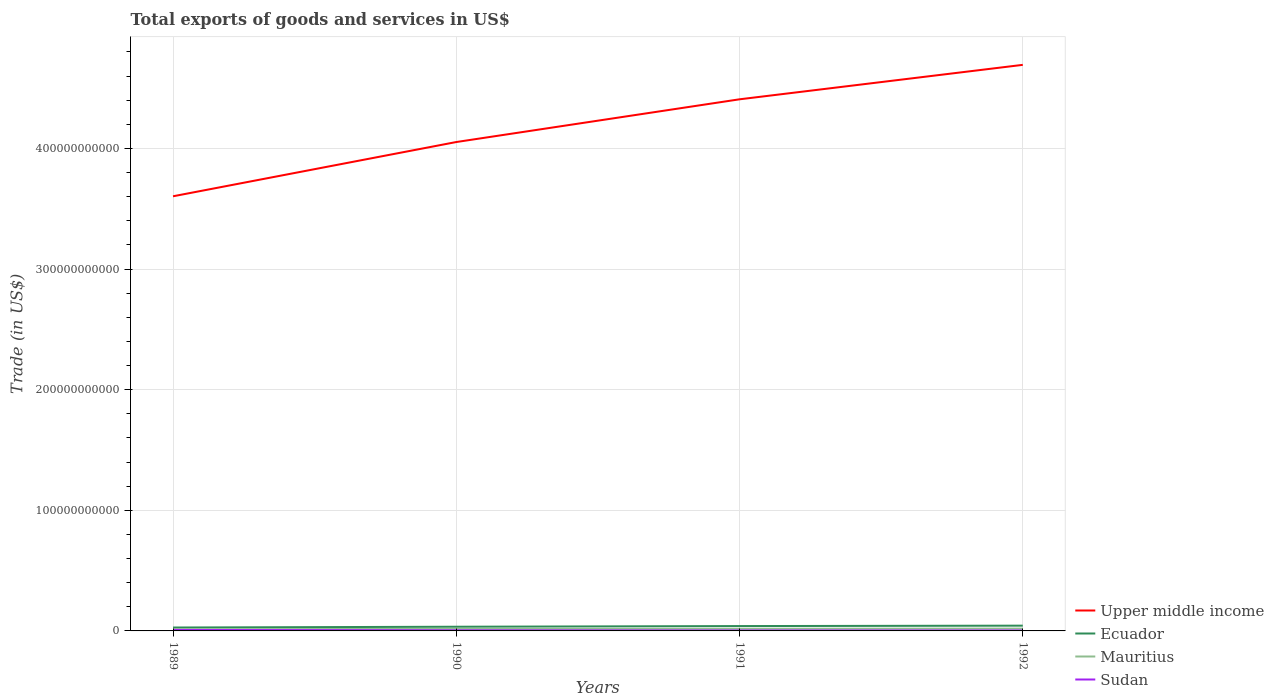How many different coloured lines are there?
Your answer should be compact. 4. Is the number of lines equal to the number of legend labels?
Ensure brevity in your answer.  Yes. Across all years, what is the maximum total exports of goods and services in Mauritius?
Make the answer very short. 1.40e+09. What is the total total exports of goods and services in Upper middle income in the graph?
Give a very brief answer. -3.54e+1. What is the difference between the highest and the second highest total exports of goods and services in Sudan?
Offer a very short reply. 4.48e+08. Is the total exports of goods and services in Mauritius strictly greater than the total exports of goods and services in Sudan over the years?
Provide a short and direct response. No. How many lines are there?
Provide a short and direct response. 4. What is the difference between two consecutive major ticks on the Y-axis?
Your answer should be very brief. 1.00e+11. Where does the legend appear in the graph?
Ensure brevity in your answer.  Bottom right. How many legend labels are there?
Keep it short and to the point. 4. What is the title of the graph?
Your response must be concise. Total exports of goods and services in US$. Does "Liechtenstein" appear as one of the legend labels in the graph?
Provide a succinct answer. No. What is the label or title of the X-axis?
Offer a very short reply. Years. What is the label or title of the Y-axis?
Ensure brevity in your answer.  Trade (in US$). What is the Trade (in US$) of Upper middle income in 1989?
Offer a very short reply. 3.60e+11. What is the Trade (in US$) in Ecuador in 1989?
Your answer should be compact. 2.82e+09. What is the Trade (in US$) of Mauritius in 1989?
Give a very brief answer. 1.40e+09. What is the Trade (in US$) in Sudan in 1989?
Your response must be concise. 8.17e+08. What is the Trade (in US$) in Upper middle income in 1990?
Your answer should be very brief. 4.05e+11. What is the Trade (in US$) in Ecuador in 1990?
Your answer should be very brief. 3.47e+09. What is the Trade (in US$) of Mauritius in 1990?
Offer a very short reply. 1.72e+09. What is the Trade (in US$) of Sudan in 1990?
Offer a very short reply. 4.99e+08. What is the Trade (in US$) of Upper middle income in 1991?
Your answer should be compact. 4.41e+11. What is the Trade (in US$) of Ecuador in 1991?
Ensure brevity in your answer.  4.02e+09. What is the Trade (in US$) of Mauritius in 1991?
Your response must be concise. 1.78e+09. What is the Trade (in US$) of Sudan in 1991?
Keep it short and to the point. 3.80e+08. What is the Trade (in US$) in Upper middle income in 1992?
Give a very brief answer. 4.69e+11. What is the Trade (in US$) in Ecuador in 1992?
Offer a terse response. 4.37e+09. What is the Trade (in US$) of Mauritius in 1992?
Your response must be concise. 1.91e+09. What is the Trade (in US$) of Sudan in 1992?
Provide a succinct answer. 3.69e+08. Across all years, what is the maximum Trade (in US$) in Upper middle income?
Provide a short and direct response. 4.69e+11. Across all years, what is the maximum Trade (in US$) in Ecuador?
Ensure brevity in your answer.  4.37e+09. Across all years, what is the maximum Trade (in US$) in Mauritius?
Your answer should be compact. 1.91e+09. Across all years, what is the maximum Trade (in US$) in Sudan?
Make the answer very short. 8.17e+08. Across all years, what is the minimum Trade (in US$) of Upper middle income?
Provide a succinct answer. 3.60e+11. Across all years, what is the minimum Trade (in US$) of Ecuador?
Ensure brevity in your answer.  2.82e+09. Across all years, what is the minimum Trade (in US$) in Mauritius?
Provide a succinct answer. 1.40e+09. Across all years, what is the minimum Trade (in US$) in Sudan?
Keep it short and to the point. 3.69e+08. What is the total Trade (in US$) of Upper middle income in the graph?
Offer a terse response. 1.68e+12. What is the total Trade (in US$) in Ecuador in the graph?
Provide a succinct answer. 1.47e+1. What is the total Trade (in US$) in Mauritius in the graph?
Your response must be concise. 6.82e+09. What is the total Trade (in US$) of Sudan in the graph?
Your answer should be compact. 2.06e+09. What is the difference between the Trade (in US$) in Upper middle income in 1989 and that in 1990?
Your answer should be very brief. -4.50e+1. What is the difference between the Trade (in US$) in Ecuador in 1989 and that in 1990?
Your answer should be compact. -6.52e+08. What is the difference between the Trade (in US$) of Mauritius in 1989 and that in 1990?
Your answer should be compact. -3.23e+08. What is the difference between the Trade (in US$) of Sudan in 1989 and that in 1990?
Provide a short and direct response. 3.18e+08. What is the difference between the Trade (in US$) of Upper middle income in 1989 and that in 1991?
Provide a succinct answer. -8.04e+1. What is the difference between the Trade (in US$) of Ecuador in 1989 and that in 1991?
Ensure brevity in your answer.  -1.20e+09. What is the difference between the Trade (in US$) of Mauritius in 1989 and that in 1991?
Make the answer very short. -3.79e+08. What is the difference between the Trade (in US$) of Sudan in 1989 and that in 1991?
Keep it short and to the point. 4.37e+08. What is the difference between the Trade (in US$) of Upper middle income in 1989 and that in 1992?
Your answer should be very brief. -1.09e+11. What is the difference between the Trade (in US$) of Ecuador in 1989 and that in 1992?
Provide a succinct answer. -1.55e+09. What is the difference between the Trade (in US$) in Mauritius in 1989 and that in 1992?
Offer a terse response. -5.11e+08. What is the difference between the Trade (in US$) of Sudan in 1989 and that in 1992?
Offer a very short reply. 4.48e+08. What is the difference between the Trade (in US$) of Upper middle income in 1990 and that in 1991?
Ensure brevity in your answer.  -3.54e+1. What is the difference between the Trade (in US$) in Ecuador in 1990 and that in 1991?
Offer a very short reply. -5.53e+08. What is the difference between the Trade (in US$) in Mauritius in 1990 and that in 1991?
Provide a short and direct response. -5.64e+07. What is the difference between the Trade (in US$) of Sudan in 1990 and that in 1991?
Offer a terse response. 1.20e+08. What is the difference between the Trade (in US$) of Upper middle income in 1990 and that in 1992?
Make the answer very short. -6.40e+1. What is the difference between the Trade (in US$) in Ecuador in 1990 and that in 1992?
Offer a very short reply. -8.98e+08. What is the difference between the Trade (in US$) of Mauritius in 1990 and that in 1992?
Provide a short and direct response. -1.89e+08. What is the difference between the Trade (in US$) of Sudan in 1990 and that in 1992?
Your answer should be very brief. 1.30e+08. What is the difference between the Trade (in US$) in Upper middle income in 1991 and that in 1992?
Your answer should be very brief. -2.86e+1. What is the difference between the Trade (in US$) in Ecuador in 1991 and that in 1992?
Your answer should be very brief. -3.45e+08. What is the difference between the Trade (in US$) of Mauritius in 1991 and that in 1992?
Provide a short and direct response. -1.32e+08. What is the difference between the Trade (in US$) of Sudan in 1991 and that in 1992?
Make the answer very short. 1.05e+07. What is the difference between the Trade (in US$) of Upper middle income in 1989 and the Trade (in US$) of Ecuador in 1990?
Provide a succinct answer. 3.57e+11. What is the difference between the Trade (in US$) of Upper middle income in 1989 and the Trade (in US$) of Mauritius in 1990?
Provide a short and direct response. 3.59e+11. What is the difference between the Trade (in US$) in Upper middle income in 1989 and the Trade (in US$) in Sudan in 1990?
Your answer should be compact. 3.60e+11. What is the difference between the Trade (in US$) in Ecuador in 1989 and the Trade (in US$) in Mauritius in 1990?
Provide a succinct answer. 1.09e+09. What is the difference between the Trade (in US$) of Ecuador in 1989 and the Trade (in US$) of Sudan in 1990?
Provide a succinct answer. 2.32e+09. What is the difference between the Trade (in US$) in Mauritius in 1989 and the Trade (in US$) in Sudan in 1990?
Provide a succinct answer. 9.02e+08. What is the difference between the Trade (in US$) in Upper middle income in 1989 and the Trade (in US$) in Ecuador in 1991?
Make the answer very short. 3.56e+11. What is the difference between the Trade (in US$) of Upper middle income in 1989 and the Trade (in US$) of Mauritius in 1991?
Your response must be concise. 3.59e+11. What is the difference between the Trade (in US$) of Upper middle income in 1989 and the Trade (in US$) of Sudan in 1991?
Provide a short and direct response. 3.60e+11. What is the difference between the Trade (in US$) in Ecuador in 1989 and the Trade (in US$) in Mauritius in 1991?
Your answer should be compact. 1.04e+09. What is the difference between the Trade (in US$) in Ecuador in 1989 and the Trade (in US$) in Sudan in 1991?
Offer a terse response. 2.44e+09. What is the difference between the Trade (in US$) in Mauritius in 1989 and the Trade (in US$) in Sudan in 1991?
Give a very brief answer. 1.02e+09. What is the difference between the Trade (in US$) in Upper middle income in 1989 and the Trade (in US$) in Ecuador in 1992?
Keep it short and to the point. 3.56e+11. What is the difference between the Trade (in US$) of Upper middle income in 1989 and the Trade (in US$) of Mauritius in 1992?
Give a very brief answer. 3.58e+11. What is the difference between the Trade (in US$) of Upper middle income in 1989 and the Trade (in US$) of Sudan in 1992?
Your answer should be very brief. 3.60e+11. What is the difference between the Trade (in US$) in Ecuador in 1989 and the Trade (in US$) in Mauritius in 1992?
Give a very brief answer. 9.05e+08. What is the difference between the Trade (in US$) in Ecuador in 1989 and the Trade (in US$) in Sudan in 1992?
Your answer should be compact. 2.45e+09. What is the difference between the Trade (in US$) of Mauritius in 1989 and the Trade (in US$) of Sudan in 1992?
Provide a short and direct response. 1.03e+09. What is the difference between the Trade (in US$) of Upper middle income in 1990 and the Trade (in US$) of Ecuador in 1991?
Give a very brief answer. 4.01e+11. What is the difference between the Trade (in US$) in Upper middle income in 1990 and the Trade (in US$) in Mauritius in 1991?
Offer a very short reply. 4.04e+11. What is the difference between the Trade (in US$) in Upper middle income in 1990 and the Trade (in US$) in Sudan in 1991?
Offer a very short reply. 4.05e+11. What is the difference between the Trade (in US$) of Ecuador in 1990 and the Trade (in US$) of Mauritius in 1991?
Offer a terse response. 1.69e+09. What is the difference between the Trade (in US$) of Ecuador in 1990 and the Trade (in US$) of Sudan in 1991?
Your answer should be compact. 3.09e+09. What is the difference between the Trade (in US$) of Mauritius in 1990 and the Trade (in US$) of Sudan in 1991?
Ensure brevity in your answer.  1.34e+09. What is the difference between the Trade (in US$) of Upper middle income in 1990 and the Trade (in US$) of Ecuador in 1992?
Keep it short and to the point. 4.01e+11. What is the difference between the Trade (in US$) in Upper middle income in 1990 and the Trade (in US$) in Mauritius in 1992?
Your response must be concise. 4.03e+11. What is the difference between the Trade (in US$) in Upper middle income in 1990 and the Trade (in US$) in Sudan in 1992?
Your response must be concise. 4.05e+11. What is the difference between the Trade (in US$) in Ecuador in 1990 and the Trade (in US$) in Mauritius in 1992?
Make the answer very short. 1.56e+09. What is the difference between the Trade (in US$) of Ecuador in 1990 and the Trade (in US$) of Sudan in 1992?
Provide a succinct answer. 3.10e+09. What is the difference between the Trade (in US$) in Mauritius in 1990 and the Trade (in US$) in Sudan in 1992?
Your answer should be compact. 1.35e+09. What is the difference between the Trade (in US$) in Upper middle income in 1991 and the Trade (in US$) in Ecuador in 1992?
Make the answer very short. 4.36e+11. What is the difference between the Trade (in US$) of Upper middle income in 1991 and the Trade (in US$) of Mauritius in 1992?
Your answer should be very brief. 4.39e+11. What is the difference between the Trade (in US$) in Upper middle income in 1991 and the Trade (in US$) in Sudan in 1992?
Give a very brief answer. 4.40e+11. What is the difference between the Trade (in US$) of Ecuador in 1991 and the Trade (in US$) of Mauritius in 1992?
Provide a short and direct response. 2.11e+09. What is the difference between the Trade (in US$) of Ecuador in 1991 and the Trade (in US$) of Sudan in 1992?
Your response must be concise. 3.65e+09. What is the difference between the Trade (in US$) in Mauritius in 1991 and the Trade (in US$) in Sudan in 1992?
Offer a very short reply. 1.41e+09. What is the average Trade (in US$) in Upper middle income per year?
Offer a terse response. 4.19e+11. What is the average Trade (in US$) in Ecuador per year?
Offer a very short reply. 3.67e+09. What is the average Trade (in US$) in Mauritius per year?
Make the answer very short. 1.70e+09. What is the average Trade (in US$) in Sudan per year?
Provide a succinct answer. 5.16e+08. In the year 1989, what is the difference between the Trade (in US$) in Upper middle income and Trade (in US$) in Ecuador?
Provide a short and direct response. 3.58e+11. In the year 1989, what is the difference between the Trade (in US$) of Upper middle income and Trade (in US$) of Mauritius?
Provide a short and direct response. 3.59e+11. In the year 1989, what is the difference between the Trade (in US$) in Upper middle income and Trade (in US$) in Sudan?
Provide a succinct answer. 3.60e+11. In the year 1989, what is the difference between the Trade (in US$) in Ecuador and Trade (in US$) in Mauritius?
Give a very brief answer. 1.42e+09. In the year 1989, what is the difference between the Trade (in US$) of Ecuador and Trade (in US$) of Sudan?
Keep it short and to the point. 2.00e+09. In the year 1989, what is the difference between the Trade (in US$) in Mauritius and Trade (in US$) in Sudan?
Provide a succinct answer. 5.84e+08. In the year 1990, what is the difference between the Trade (in US$) in Upper middle income and Trade (in US$) in Ecuador?
Your answer should be compact. 4.02e+11. In the year 1990, what is the difference between the Trade (in US$) of Upper middle income and Trade (in US$) of Mauritius?
Your answer should be very brief. 4.04e+11. In the year 1990, what is the difference between the Trade (in US$) in Upper middle income and Trade (in US$) in Sudan?
Your response must be concise. 4.05e+11. In the year 1990, what is the difference between the Trade (in US$) of Ecuador and Trade (in US$) of Mauritius?
Your answer should be very brief. 1.75e+09. In the year 1990, what is the difference between the Trade (in US$) of Ecuador and Trade (in US$) of Sudan?
Give a very brief answer. 2.97e+09. In the year 1990, what is the difference between the Trade (in US$) of Mauritius and Trade (in US$) of Sudan?
Make the answer very short. 1.22e+09. In the year 1991, what is the difference between the Trade (in US$) of Upper middle income and Trade (in US$) of Ecuador?
Provide a succinct answer. 4.37e+11. In the year 1991, what is the difference between the Trade (in US$) of Upper middle income and Trade (in US$) of Mauritius?
Give a very brief answer. 4.39e+11. In the year 1991, what is the difference between the Trade (in US$) of Upper middle income and Trade (in US$) of Sudan?
Your answer should be compact. 4.40e+11. In the year 1991, what is the difference between the Trade (in US$) in Ecuador and Trade (in US$) in Mauritius?
Make the answer very short. 2.24e+09. In the year 1991, what is the difference between the Trade (in US$) in Ecuador and Trade (in US$) in Sudan?
Your response must be concise. 3.64e+09. In the year 1991, what is the difference between the Trade (in US$) of Mauritius and Trade (in US$) of Sudan?
Offer a terse response. 1.40e+09. In the year 1992, what is the difference between the Trade (in US$) in Upper middle income and Trade (in US$) in Ecuador?
Offer a terse response. 4.65e+11. In the year 1992, what is the difference between the Trade (in US$) of Upper middle income and Trade (in US$) of Mauritius?
Your answer should be compact. 4.67e+11. In the year 1992, what is the difference between the Trade (in US$) in Upper middle income and Trade (in US$) in Sudan?
Offer a very short reply. 4.69e+11. In the year 1992, what is the difference between the Trade (in US$) in Ecuador and Trade (in US$) in Mauritius?
Offer a terse response. 2.45e+09. In the year 1992, what is the difference between the Trade (in US$) in Ecuador and Trade (in US$) in Sudan?
Offer a very short reply. 4.00e+09. In the year 1992, what is the difference between the Trade (in US$) in Mauritius and Trade (in US$) in Sudan?
Keep it short and to the point. 1.54e+09. What is the ratio of the Trade (in US$) in Upper middle income in 1989 to that in 1990?
Keep it short and to the point. 0.89. What is the ratio of the Trade (in US$) in Ecuador in 1989 to that in 1990?
Your answer should be compact. 0.81. What is the ratio of the Trade (in US$) of Mauritius in 1989 to that in 1990?
Offer a terse response. 0.81. What is the ratio of the Trade (in US$) in Sudan in 1989 to that in 1990?
Provide a succinct answer. 1.64. What is the ratio of the Trade (in US$) in Upper middle income in 1989 to that in 1991?
Provide a succinct answer. 0.82. What is the ratio of the Trade (in US$) of Ecuador in 1989 to that in 1991?
Keep it short and to the point. 0.7. What is the ratio of the Trade (in US$) of Mauritius in 1989 to that in 1991?
Offer a very short reply. 0.79. What is the ratio of the Trade (in US$) in Sudan in 1989 to that in 1991?
Give a very brief answer. 2.15. What is the ratio of the Trade (in US$) in Upper middle income in 1989 to that in 1992?
Give a very brief answer. 0.77. What is the ratio of the Trade (in US$) in Ecuador in 1989 to that in 1992?
Give a very brief answer. 0.65. What is the ratio of the Trade (in US$) of Mauritius in 1989 to that in 1992?
Offer a very short reply. 0.73. What is the ratio of the Trade (in US$) of Sudan in 1989 to that in 1992?
Offer a terse response. 2.21. What is the ratio of the Trade (in US$) of Upper middle income in 1990 to that in 1991?
Give a very brief answer. 0.92. What is the ratio of the Trade (in US$) of Ecuador in 1990 to that in 1991?
Provide a short and direct response. 0.86. What is the ratio of the Trade (in US$) in Mauritius in 1990 to that in 1991?
Your answer should be compact. 0.97. What is the ratio of the Trade (in US$) in Sudan in 1990 to that in 1991?
Your response must be concise. 1.31. What is the ratio of the Trade (in US$) of Upper middle income in 1990 to that in 1992?
Provide a short and direct response. 0.86. What is the ratio of the Trade (in US$) in Ecuador in 1990 to that in 1992?
Make the answer very short. 0.79. What is the ratio of the Trade (in US$) of Mauritius in 1990 to that in 1992?
Your answer should be very brief. 0.9. What is the ratio of the Trade (in US$) in Sudan in 1990 to that in 1992?
Make the answer very short. 1.35. What is the ratio of the Trade (in US$) of Upper middle income in 1991 to that in 1992?
Provide a short and direct response. 0.94. What is the ratio of the Trade (in US$) of Ecuador in 1991 to that in 1992?
Your answer should be very brief. 0.92. What is the ratio of the Trade (in US$) of Mauritius in 1991 to that in 1992?
Provide a short and direct response. 0.93. What is the ratio of the Trade (in US$) of Sudan in 1991 to that in 1992?
Make the answer very short. 1.03. What is the difference between the highest and the second highest Trade (in US$) in Upper middle income?
Make the answer very short. 2.86e+1. What is the difference between the highest and the second highest Trade (in US$) in Ecuador?
Your response must be concise. 3.45e+08. What is the difference between the highest and the second highest Trade (in US$) in Mauritius?
Your answer should be very brief. 1.32e+08. What is the difference between the highest and the second highest Trade (in US$) of Sudan?
Make the answer very short. 3.18e+08. What is the difference between the highest and the lowest Trade (in US$) of Upper middle income?
Ensure brevity in your answer.  1.09e+11. What is the difference between the highest and the lowest Trade (in US$) in Ecuador?
Keep it short and to the point. 1.55e+09. What is the difference between the highest and the lowest Trade (in US$) of Mauritius?
Your answer should be very brief. 5.11e+08. What is the difference between the highest and the lowest Trade (in US$) of Sudan?
Give a very brief answer. 4.48e+08. 